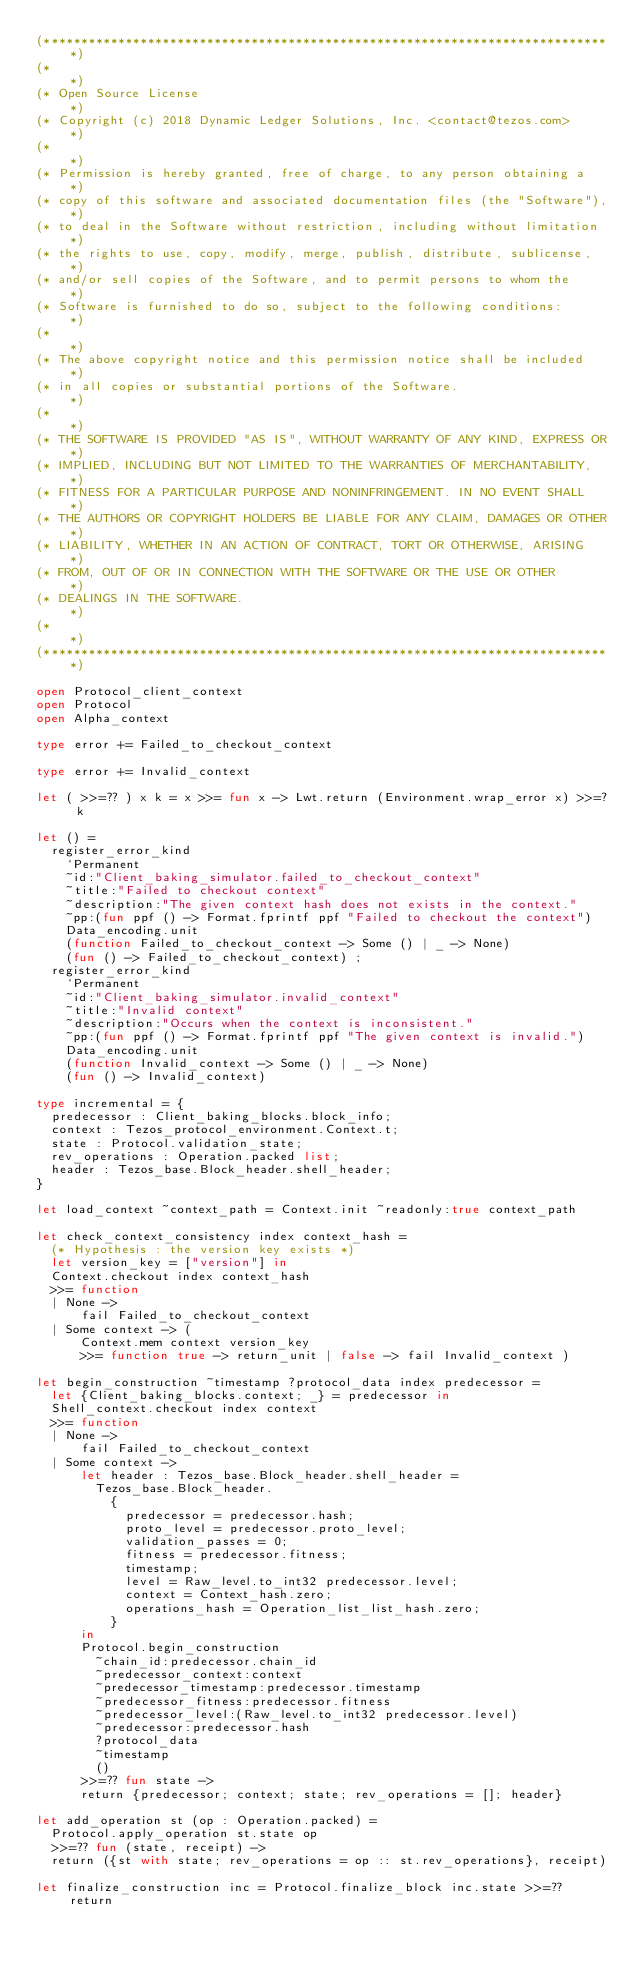Convert code to text. <code><loc_0><loc_0><loc_500><loc_500><_OCaml_>(*****************************************************************************)
(*                                                                           *)
(* Open Source License                                                       *)
(* Copyright (c) 2018 Dynamic Ledger Solutions, Inc. <contact@tezos.com>     *)
(*                                                                           *)
(* Permission is hereby granted, free of charge, to any person obtaining a   *)
(* copy of this software and associated documentation files (the "Software"),*)
(* to deal in the Software without restriction, including without limitation *)
(* the rights to use, copy, modify, merge, publish, distribute, sublicense,  *)
(* and/or sell copies of the Software, and to permit persons to whom the     *)
(* Software is furnished to do so, subject to the following conditions:      *)
(*                                                                           *)
(* The above copyright notice and this permission notice shall be included   *)
(* in all copies or substantial portions of the Software.                    *)
(*                                                                           *)
(* THE SOFTWARE IS PROVIDED "AS IS", WITHOUT WARRANTY OF ANY KIND, EXPRESS OR*)
(* IMPLIED, INCLUDING BUT NOT LIMITED TO THE WARRANTIES OF MERCHANTABILITY,  *)
(* FITNESS FOR A PARTICULAR PURPOSE AND NONINFRINGEMENT. IN NO EVENT SHALL   *)
(* THE AUTHORS OR COPYRIGHT HOLDERS BE LIABLE FOR ANY CLAIM, DAMAGES OR OTHER*)
(* LIABILITY, WHETHER IN AN ACTION OF CONTRACT, TORT OR OTHERWISE, ARISING   *)
(* FROM, OUT OF OR IN CONNECTION WITH THE SOFTWARE OR THE USE OR OTHER       *)
(* DEALINGS IN THE SOFTWARE.                                                 *)
(*                                                                           *)
(*****************************************************************************)

open Protocol_client_context
open Protocol
open Alpha_context

type error += Failed_to_checkout_context

type error += Invalid_context

let ( >>=?? ) x k = x >>= fun x -> Lwt.return (Environment.wrap_error x) >>=? k

let () =
  register_error_kind
    `Permanent
    ~id:"Client_baking_simulator.failed_to_checkout_context"
    ~title:"Failed to checkout context"
    ~description:"The given context hash does not exists in the context."
    ~pp:(fun ppf () -> Format.fprintf ppf "Failed to checkout the context")
    Data_encoding.unit
    (function Failed_to_checkout_context -> Some () | _ -> None)
    (fun () -> Failed_to_checkout_context) ;
  register_error_kind
    `Permanent
    ~id:"Client_baking_simulator.invalid_context"
    ~title:"Invalid context"
    ~description:"Occurs when the context is inconsistent."
    ~pp:(fun ppf () -> Format.fprintf ppf "The given context is invalid.")
    Data_encoding.unit
    (function Invalid_context -> Some () | _ -> None)
    (fun () -> Invalid_context)

type incremental = {
  predecessor : Client_baking_blocks.block_info;
  context : Tezos_protocol_environment.Context.t;
  state : Protocol.validation_state;
  rev_operations : Operation.packed list;
  header : Tezos_base.Block_header.shell_header;
}

let load_context ~context_path = Context.init ~readonly:true context_path

let check_context_consistency index context_hash =
  (* Hypothesis : the version key exists *)
  let version_key = ["version"] in
  Context.checkout index context_hash
  >>= function
  | None ->
      fail Failed_to_checkout_context
  | Some context -> (
      Context.mem context version_key
      >>= function true -> return_unit | false -> fail Invalid_context )

let begin_construction ~timestamp ?protocol_data index predecessor =
  let {Client_baking_blocks.context; _} = predecessor in
  Shell_context.checkout index context
  >>= function
  | None ->
      fail Failed_to_checkout_context
  | Some context ->
      let header : Tezos_base.Block_header.shell_header =
        Tezos_base.Block_header.
          {
            predecessor = predecessor.hash;
            proto_level = predecessor.proto_level;
            validation_passes = 0;
            fitness = predecessor.fitness;
            timestamp;
            level = Raw_level.to_int32 predecessor.level;
            context = Context_hash.zero;
            operations_hash = Operation_list_list_hash.zero;
          }
      in
      Protocol.begin_construction
        ~chain_id:predecessor.chain_id
        ~predecessor_context:context
        ~predecessor_timestamp:predecessor.timestamp
        ~predecessor_fitness:predecessor.fitness
        ~predecessor_level:(Raw_level.to_int32 predecessor.level)
        ~predecessor:predecessor.hash
        ?protocol_data
        ~timestamp
        ()
      >>=?? fun state ->
      return {predecessor; context; state; rev_operations = []; header}

let add_operation st (op : Operation.packed) =
  Protocol.apply_operation st.state op
  >>=?? fun (state, receipt) ->
  return ({st with state; rev_operations = op :: st.rev_operations}, receipt)

let finalize_construction inc = Protocol.finalize_block inc.state >>=?? return
</code> 